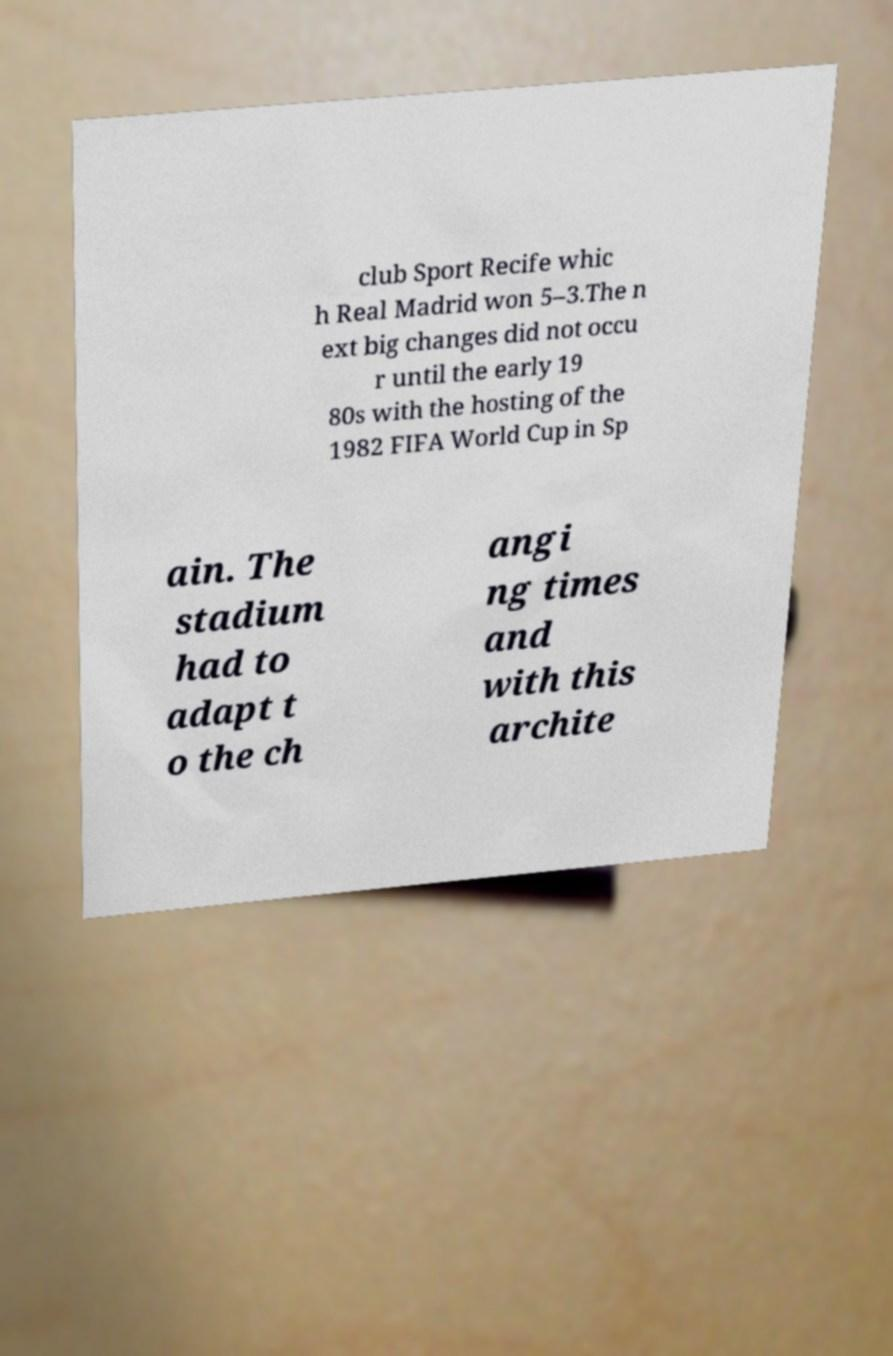For documentation purposes, I need the text within this image transcribed. Could you provide that? club Sport Recife whic h Real Madrid won 5–3.The n ext big changes did not occu r until the early 19 80s with the hosting of the 1982 FIFA World Cup in Sp ain. The stadium had to adapt t o the ch angi ng times and with this archite 